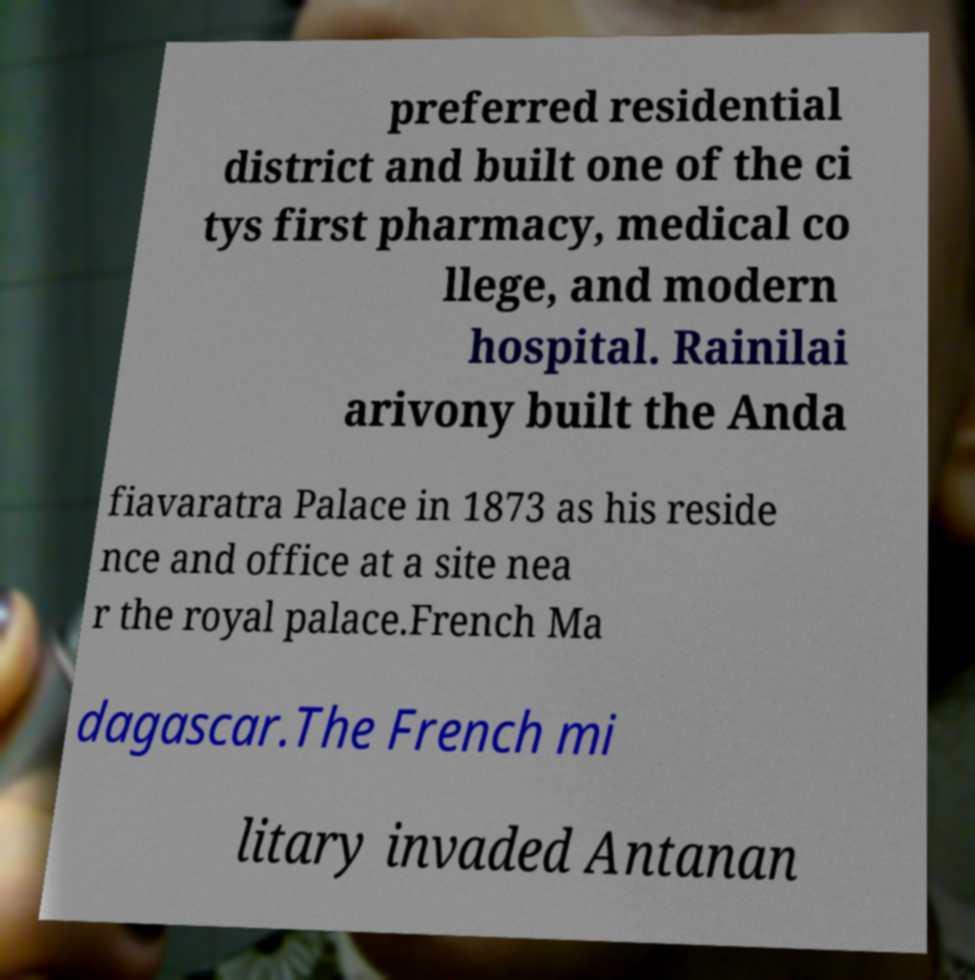Please read and relay the text visible in this image. What does it say? preferred residential district and built one of the ci tys first pharmacy, medical co llege, and modern hospital. Rainilai arivony built the Anda fiavaratra Palace in 1873 as his reside nce and office at a site nea r the royal palace.French Ma dagascar.The French mi litary invaded Antanan 